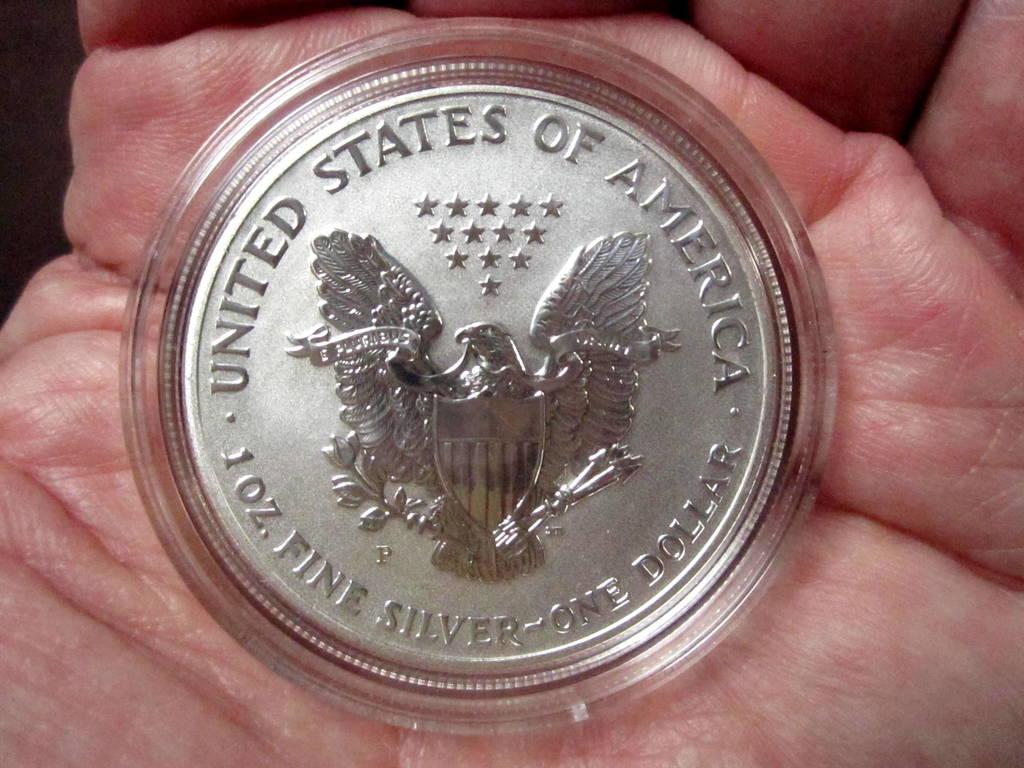<image>
Give a short and clear explanation of the subsequent image. A coin with the United States of America written on it. 